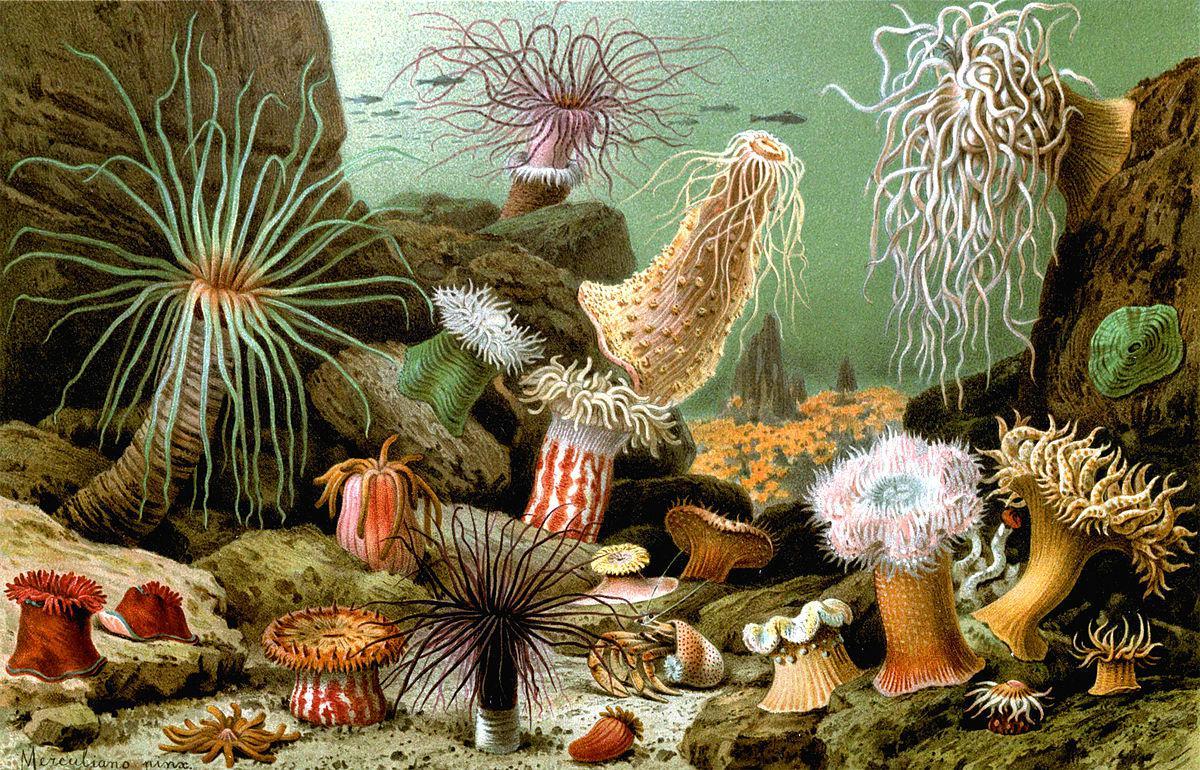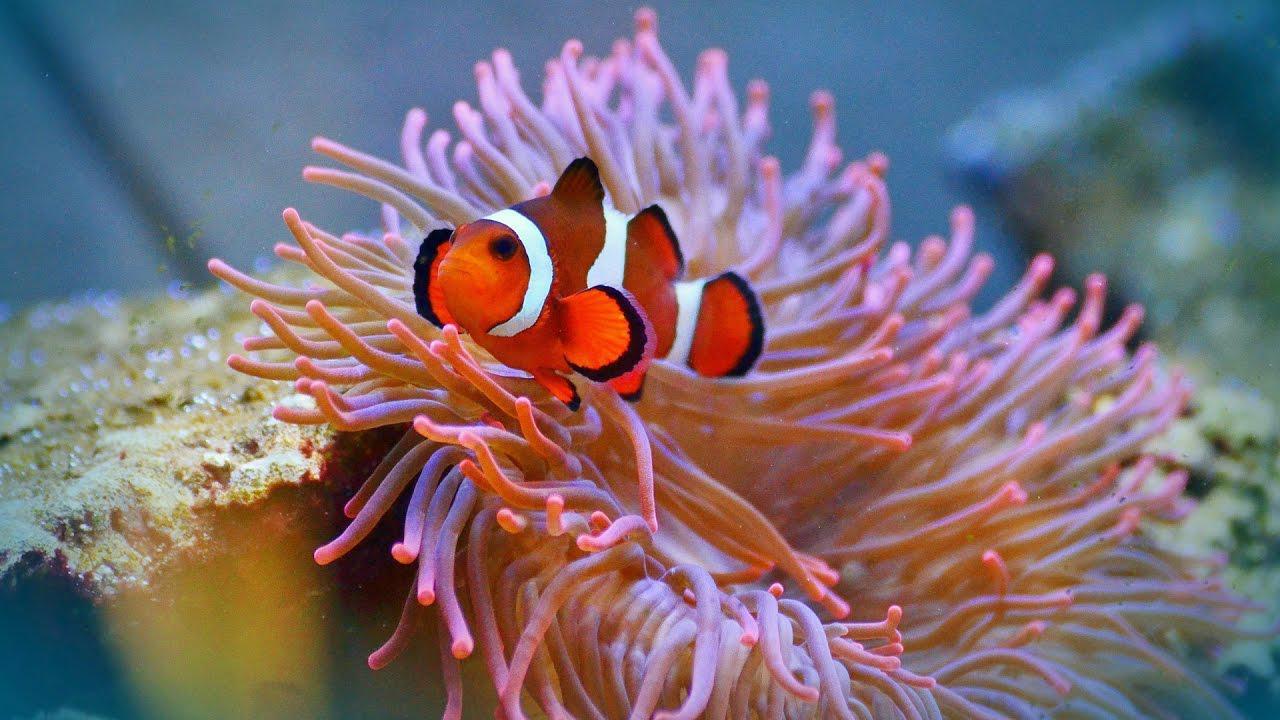The first image is the image on the left, the second image is the image on the right. Considering the images on both sides, is "In both images the fish are near the sea anemone" valid? Answer yes or no. No. 